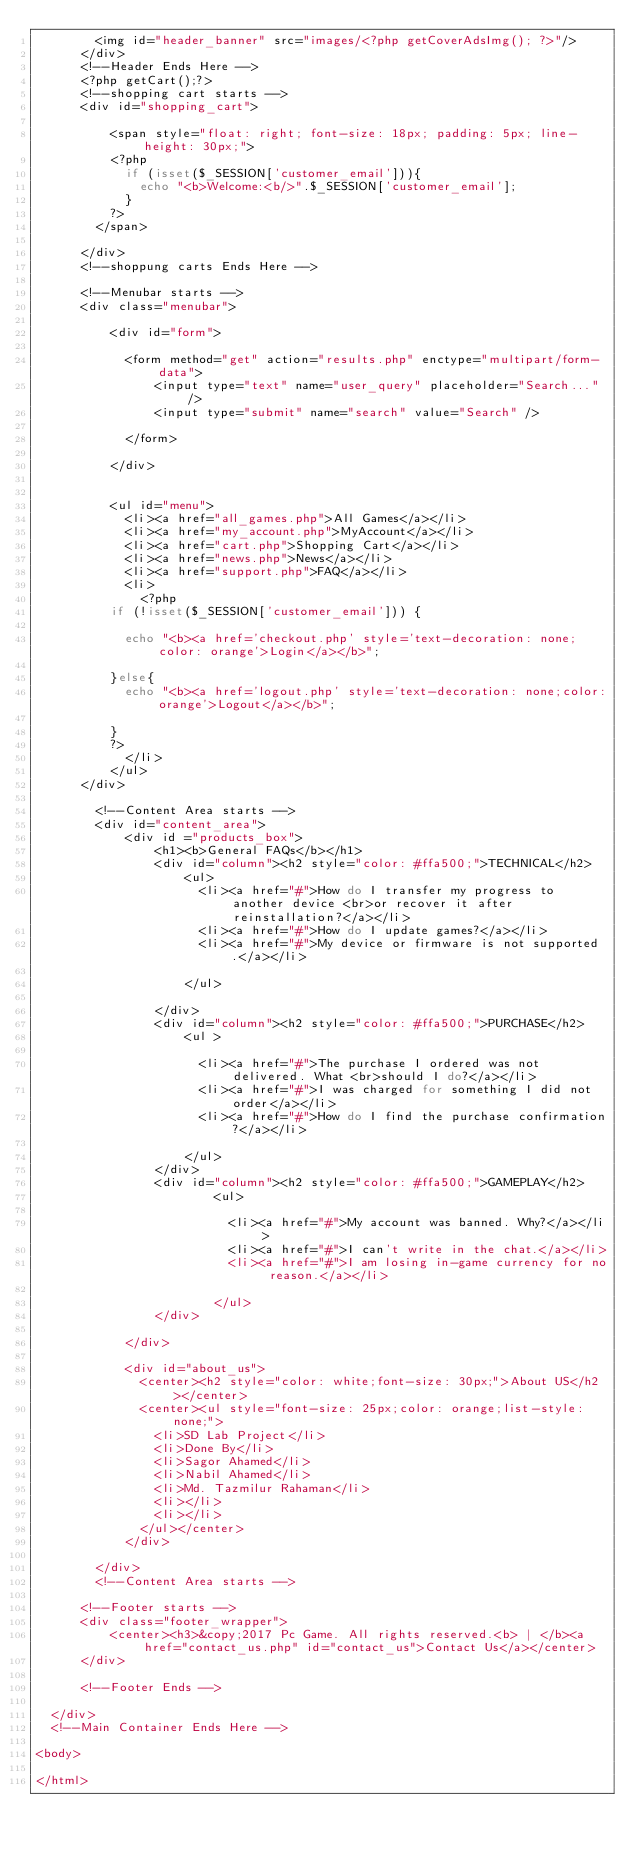Convert code to text. <code><loc_0><loc_0><loc_500><loc_500><_PHP_>				<img id="header_banner" src="images/<?php getCoverAdsImg(); ?>"/>
			</div>
			<!--Header Ends Here -->
			<?php getCart();?>
			<!--shopping cart starts -->
			<div id="shopping_cart">

					<span style="float: right; font-size: 18px; padding: 5px; line-height: 30px;">
					<?php
						if (isset($_SESSION['customer_email'])){
							echo "<b>Welcome:<b/>".$_SESSION['customer_email'];
						}
					?>
				</span>

			</div>
			<!--shoppung carts Ends Here -->

			<!--Menubar starts -->
			<div class="menubar">

					<div id="form">
						
						<form method="get" action="results.php" enctype="multipart/form-data">
								<input type="text" name="user_query" placeholder="Search..." />
								<input type="submit" name="search" value="Search" />

						</form>

					</div>


					<ul id="menu">
						<li><a href="all_games.php">All Games</a></li>
						<li><a href="my_account.php">MyAccount</a></li>
						<li><a href="cart.php">Shopping Cart</a></li>
						<li><a href="news.php">News</a></li>
						<li><a href="support.php">FAQ</a></li>
						<li>
							<?php
					if (!isset($_SESSION['customer_email'])) {

						echo "<b><a href='checkout.php' style='text-decoration: none;color: orange'>Login</a></b>";

					}else{
						echo "<b><a href='logout.php' style='text-decoration: none;color:orange'>Logout</a></b>";

					}
					?>
						</li>
					</ul>
			</div>
				
				<!--Content Area starts -->
				<div id="content_area">
						<div id ="products_box">
								<h1><b>General FAQs</b></h1>
								<div id="column"><h2 style="color: #ffa500;">TECHNICAL</h2>
										<ul>
											<li><a href="#">How do I transfer my progress to another device <br>or recover it after reinstallation?</a></li>
											<li><a href="#">How do I update games?</a></li>
											<li><a href="#">My device or firmware is not supported.</a></li>
											
										</ul>

   							</div>
								<div id="column"><h2 style="color: #ffa500;">PURCHASE</h2>
										<ul >
						
											<li><a href="#">The purchase I ordered was not delivered. What <br>should I do?</a></li>
											<li><a href="#">I was charged for something I did not order</a></li>
											<li><a href="#">How do I find the purchase confirmation?</a></li>

										</ul>
    						</div>
								<div id="column"><h2 style="color: #ffa500;">GAMEPLAY</h2>
												<ul>
						
													<li><a href="#">My account was banned. Why?</a></li>
													<li><a href="#">I can't write in the chat.</a></li>
													<li><a href="#">I am losing in-game currency for no reason.</a></li>
													
												</ul>	
    						</div>

						</div>

						<div id="about_us">
							<center><h2 style="color: white;font-size: 30px;">About US</h2></center>
							<center><ul style="font-size: 25px;color: orange;list-style: none;">
								<li>SD Lab Project</li>
								<li>Done By</li>
								<li>Sagor Ahamed</li>
								<li>Nabil Ahamed</li>
								<li>Md. Tazmilur Rahaman</li>
								<li></li>
								<li></li>
							</ul></center>
						</div>

				</div>
				<!--Content Area starts -->
			
			<!--Footer starts -->
			<div class="footer_wrapper">
					<center><h3>&copy;2017 Pc Game. All rights reserved.<b> | </b><a href="contact_us.php" id="contact_us">Contact Us</a></center>
			</div>

			<!--Footer Ends -->

	</div>
	<!--Main Container Ends Here -->

<body>

</html>
</code> 